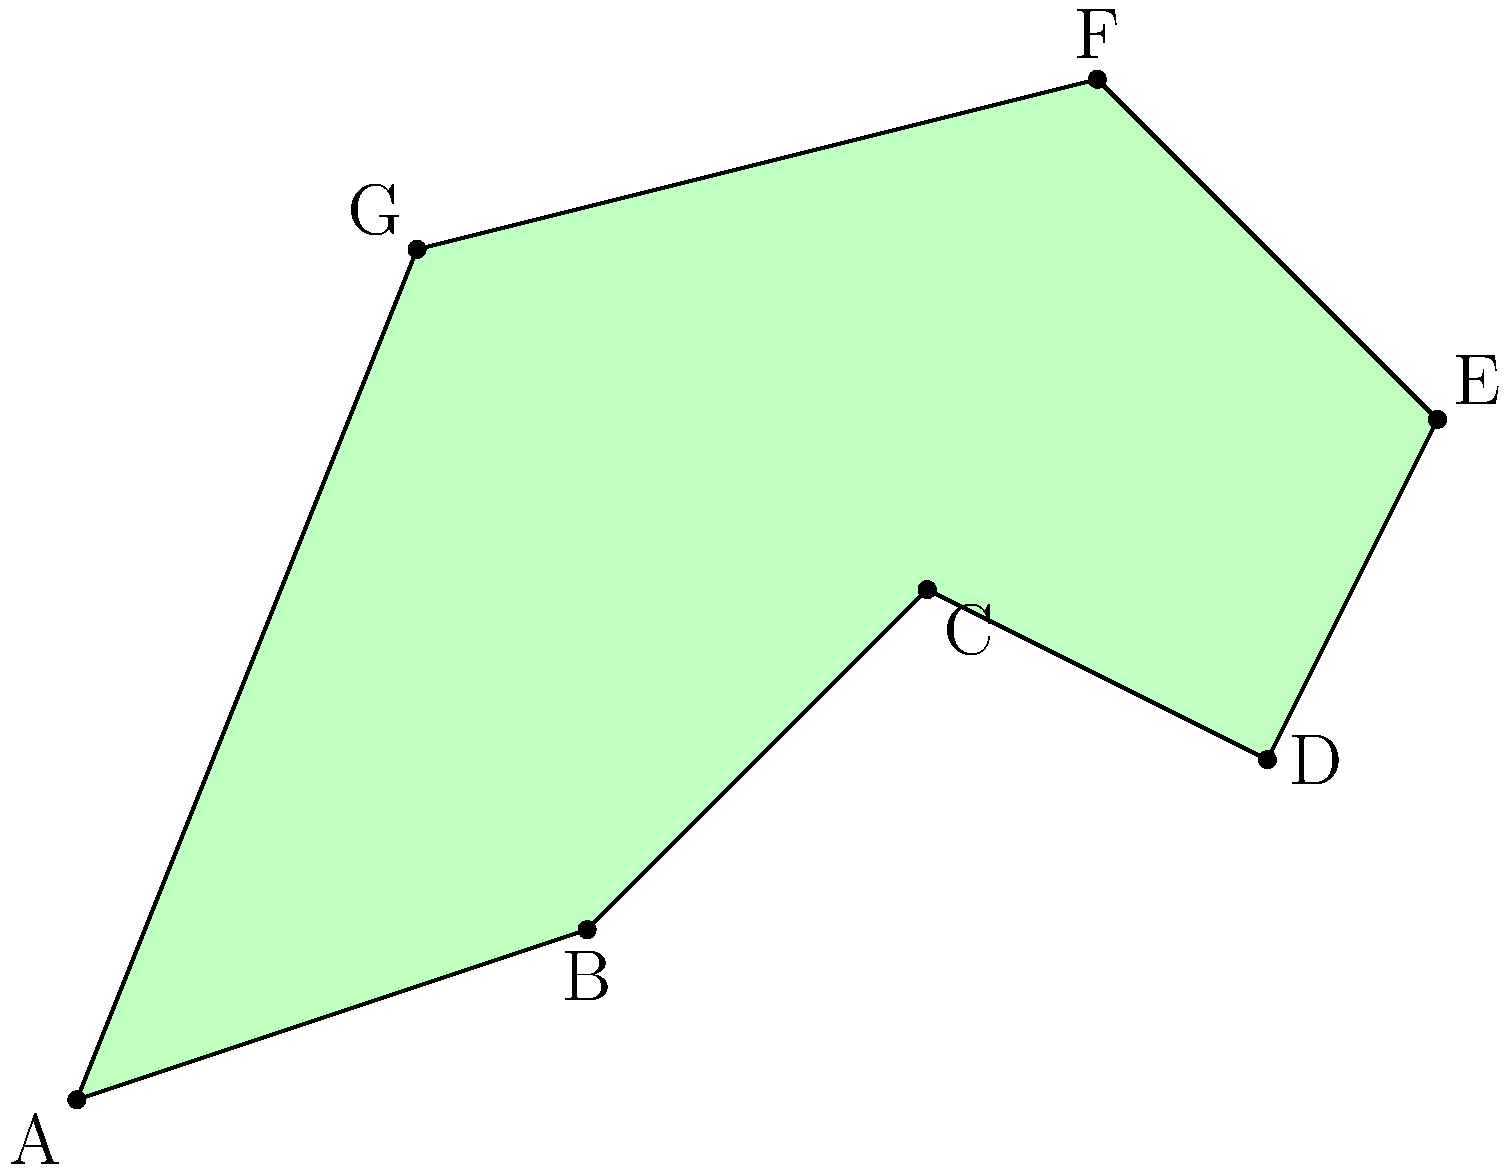As part of a reef protection initiative, you need to calculate the area of an irregularly shaped protected zone. The zone is represented by the polygon ABCDEFG in the diagram, where each unit represents 1 km. Using the shoelace formula, determine the area of this protected reef zone in square kilometers. To calculate the area of the irregular polygon representing the protected reef zone, we'll use the shoelace formula:

$$ \text{Area} = \frac{1}{2}|\sum_{i=1}^{n-1} (x_i y_{i+1} + x_n y_1) - \sum_{i=1}^{n-1} (y_i x_{i+1} + y_n x_1)| $$

Where $(x_i, y_i)$ are the coordinates of each vertex.

Step 1: Identify the coordinates of each vertex:
A(0,0), B(3,1), C(5,3), D(7,2), E(8,4), F(6,6), G(2,5)

Step 2: Apply the shoelace formula:

$$ \begin{align*}
\text{Area} &= \frac{1}{2}|(0 \cdot 1 + 3 \cdot 3 + 5 \cdot 2 + 7 \cdot 4 + 8 \cdot 6 + 6 \cdot 5 + 2 \cdot 0) \\
&- (0 \cdot 3 + 1 \cdot 5 + 3 \cdot 7 + 2 \cdot 8 + 4 \cdot 6 + 6 \cdot 2 + 5 \cdot 0)|
\end{align*} $$

Step 3: Calculate the sums:

$$ \begin{align*}
\text{Area} &= \frac{1}{2}|(0 + 9 + 10 + 28 + 48 + 30 + 0) - (0 + 5 + 21 + 16 + 24 + 12 + 0)| \\
&= \frac{1}{2}|125 - 78| \\
&= \frac{1}{2} \cdot 47 \\
&= 23.5
\end{align*} $$

Therefore, the area of the protected reef zone is 23.5 square kilometers.
Answer: 23.5 km² 